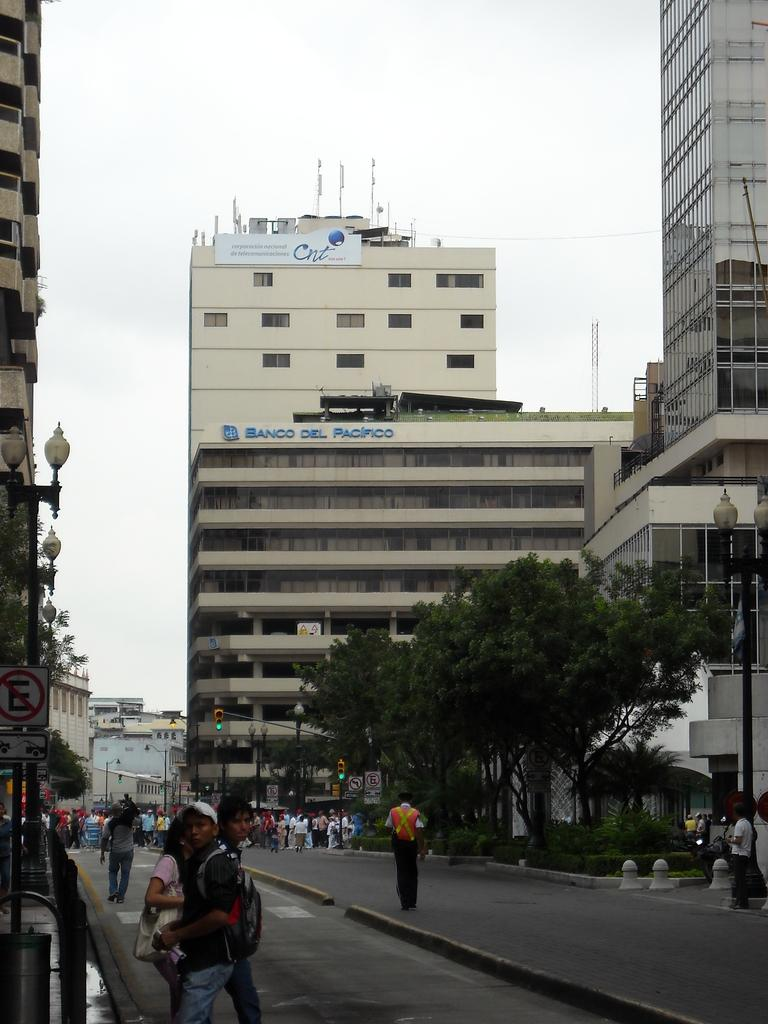<image>
Describe the image concisely. People mill about on the streets and sidewalk below the Banco Del Pacifio building. 